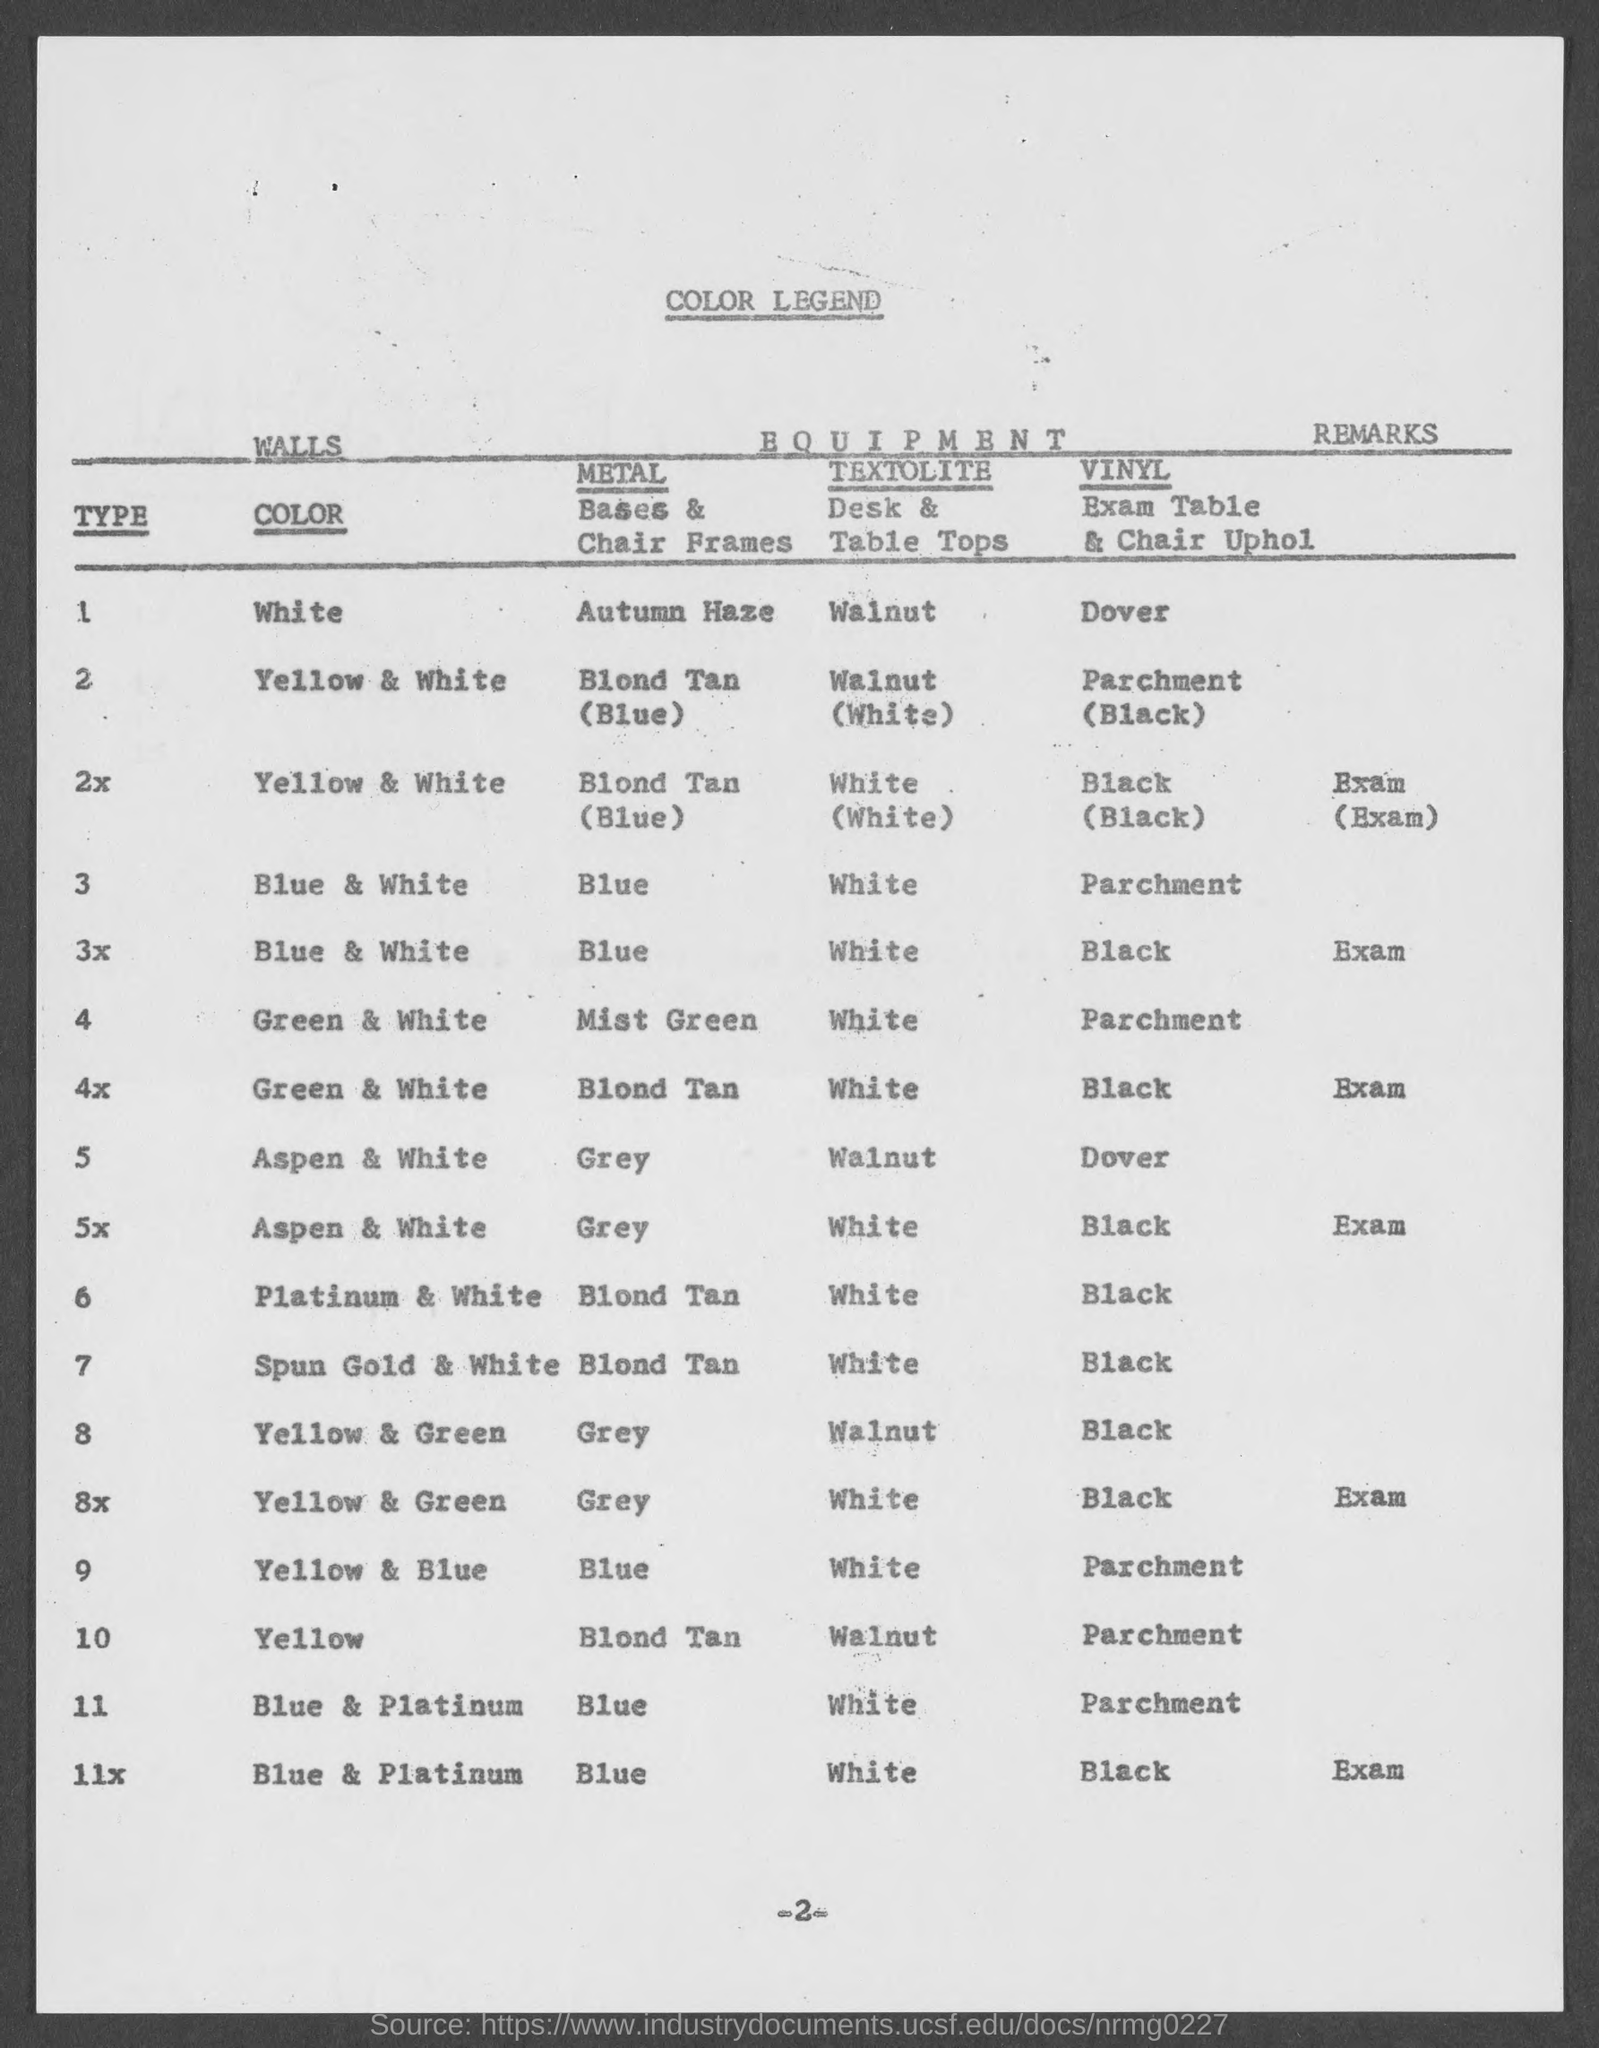Point out several critical features in this image. The page number is -2-. The title of the document is 'COLOR LEGEND'. The metal that is predominantly yellow in color is called Blond Tan. 